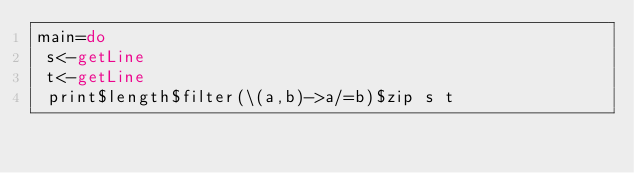Convert code to text. <code><loc_0><loc_0><loc_500><loc_500><_Haskell_>main=do
 s<-getLine
 t<-getLine
 print$length$filter(\(a,b)->a/=b)$zip s t</code> 